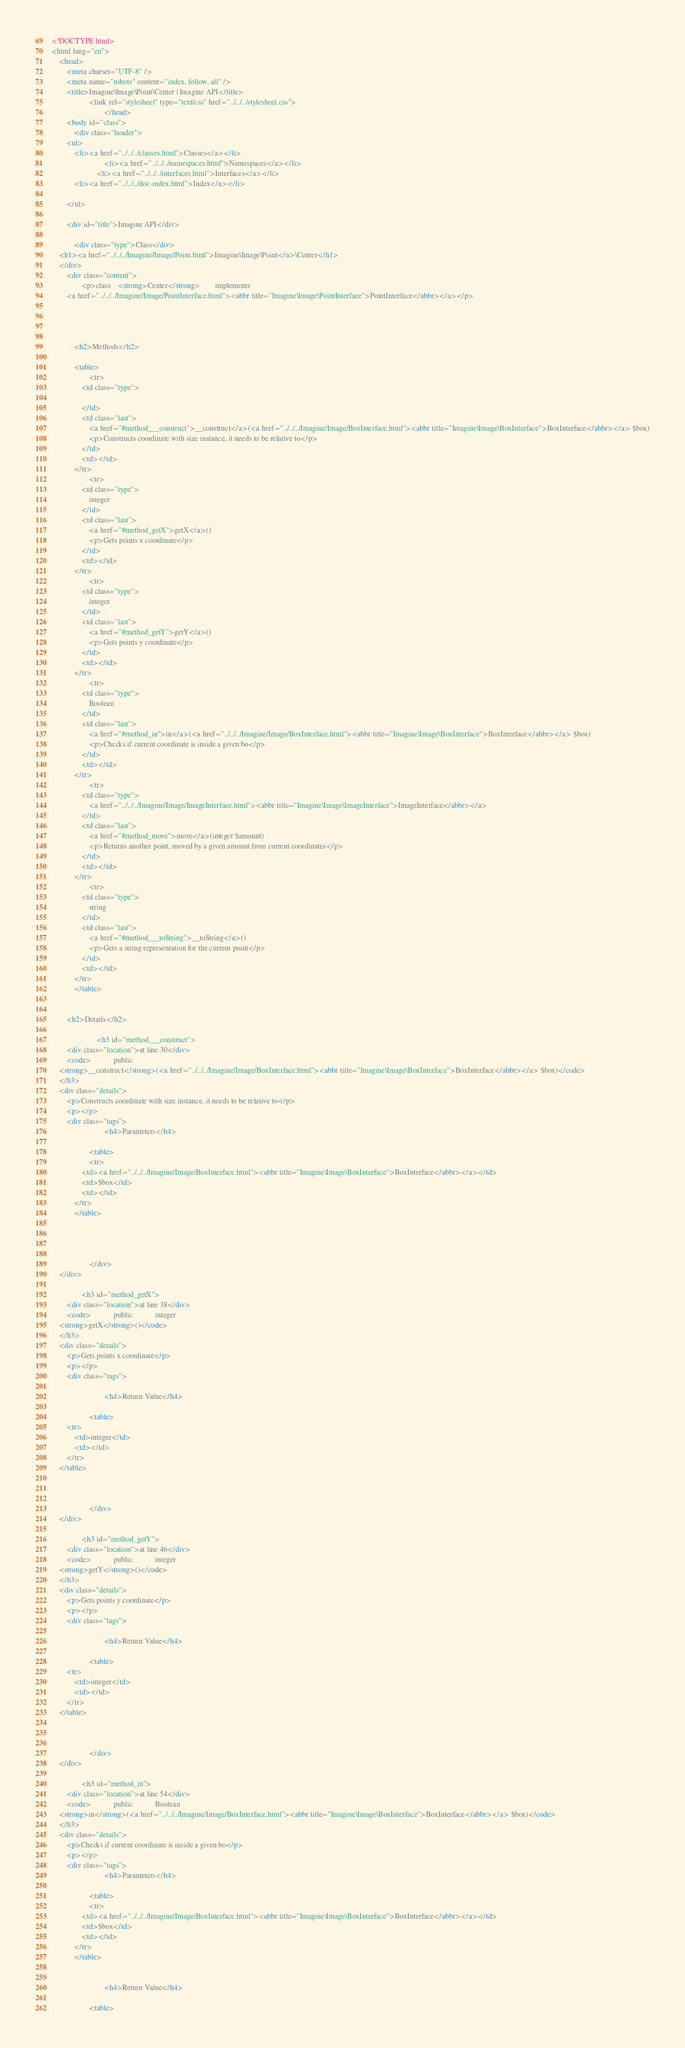Convert code to text. <code><loc_0><loc_0><loc_500><loc_500><_HTML_><!DOCTYPE html>
<html lang="en">
    <head>
        <meta charset="UTF-8" />
        <meta name="robots" content="index, follow, all" />
        <title>Imagine\Image\Point\Center | Imagine API</title>
                    <link rel="stylesheet" type="text/css" href="../../../stylesheet.css">
                            </head>
        <body id="class">
            <div class="header">
        <ul>
            <li><a href="../../../classes.html">Classes</a></li>
                            <li><a href="../../../namespaces.html">Namespaces</a></li>
                        <li><a href="../../../interfaces.html">Interfaces</a></li>
            <li><a href="../../../doc-index.html">Index</a></li>
            
        </ul>

        <div id="title">Imagine API</div>

            <div class="type">Class</div>
    <h1><a href="../../../Imagine/Image/Point.html">Imagine\Image\Point</a>\Center</h1>
    </div>
        <div class="content">
                <p>class    <strong>Center</strong>        implements
        <a href="../../../Imagine/Image/PointInterface.html"><abbr title="Imagine\Image\PointInterface">PointInterface</abbr></a></p>

    
    
    
            <h2>Methods</h2>

            <table>
                    <tr>
                <td class="type">
                    
                </td>
                <td class="last">
                    <a href="#method___construct">__construct</a>(<a href="../../../Imagine/Image/BoxInterface.html"><abbr title="Imagine\Image\BoxInterface">BoxInterface</abbr></a> $box)
                    <p>Constructs coordinate with size instance, it needs to be relative to</p>
                </td>
                <td></td>
            </tr>
                    <tr>
                <td class="type">
                    integer
                </td>
                <td class="last">
                    <a href="#method_getX">getX</a>()
                    <p>Gets points x coordinate</p>
                </td>
                <td></td>
            </tr>
                    <tr>
                <td class="type">
                    integer
                </td>
                <td class="last">
                    <a href="#method_getY">getY</a>()
                    <p>Gets points y coordinate</p>
                </td>
                <td></td>
            </tr>
                    <tr>
                <td class="type">
                    Boolean
                </td>
                <td class="last">
                    <a href="#method_in">in</a>(<a href="../../../Imagine/Image/BoxInterface.html"><abbr title="Imagine\Image\BoxInterface">BoxInterface</abbr></a> $box)
                    <p>Checks if current coordinate is inside a given bo</p>
                </td>
                <td></td>
            </tr>
                    <tr>
                <td class="type">
                    <a href="../../../Imagine/Image/ImageInterface.html"><abbr title="Imagine\Image\ImageInterface">ImageInterface</abbr></a>
                </td>
                <td class="last">
                    <a href="#method_move">move</a>(integer $amount)
                    <p>Returns another point, moved by a given amount from current coordinates</p>
                </td>
                <td></td>
            </tr>
                    <tr>
                <td class="type">
                    string
                </td>
                <td class="last">
                    <a href="#method___toString">__toString</a>()
                    <p>Gets a string representation for the current point</p>
                </td>
                <td></td>
            </tr>
            </table>


        <h2>Details</h2>

                        <h3 id="method___construct">
        <div class="location">at line 30</div>
        <code>            public            
    <strong>__construct</strong>(<a href="../../../Imagine/Image/BoxInterface.html"><abbr title="Imagine\Image\BoxInterface">BoxInterface</abbr></a> $box)</code>
    </h3>
    <div class="details">
        <p>Constructs coordinate with size instance, it needs to be relative to</p>
        <p></p>
        <div class="tags">
                            <h4>Parameters</h4>

                    <table>
                    <tr>
                <td><a href="../../../Imagine/Image/BoxInterface.html"><abbr title="Imagine\Image\BoxInterface">BoxInterface</abbr></a></td>
                <td>$box</td>
                <td></td>
            </tr>
            </table>

            
            
            
                    </div>
    </div>

                <h3 id="method_getX">
        <div class="location">at line 38</div>
        <code>            public            integer
    <strong>getX</strong>()</code>
    </h3>
    <div class="details">
        <p>Gets points x coordinate</p>
        <p></p>
        <div class="tags">
            
                            <h4>Return Value</h4>

                    <table>
        <tr>
            <td>integer</td>
            <td></td>
        </tr>
    </table>

            
            
                    </div>
    </div>

                <h3 id="method_getY">
        <div class="location">at line 46</div>
        <code>            public            integer
    <strong>getY</strong>()</code>
    </h3>
    <div class="details">
        <p>Gets points y coordinate</p>
        <p></p>
        <div class="tags">
            
                            <h4>Return Value</h4>

                    <table>
        <tr>
            <td>integer</td>
            <td></td>
        </tr>
    </table>

            
            
                    </div>
    </div>

                <h3 id="method_in">
        <div class="location">at line 54</div>
        <code>            public            Boolean
    <strong>in</strong>(<a href="../../../Imagine/Image/BoxInterface.html"><abbr title="Imagine\Image\BoxInterface">BoxInterface</abbr></a> $box)</code>
    </h3>
    <div class="details">
        <p>Checks if current coordinate is inside a given bo</p>
        <p></p>
        <div class="tags">
                            <h4>Parameters</h4>

                    <table>
                    <tr>
                <td><a href="../../../Imagine/Image/BoxInterface.html"><abbr title="Imagine\Image\BoxInterface">BoxInterface</abbr></a></td>
                <td>$box</td>
                <td></td>
            </tr>
            </table>

            
                            <h4>Return Value</h4>

                    <table></code> 